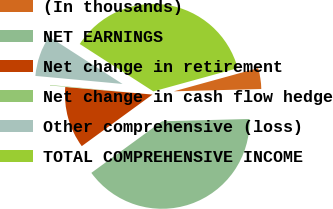<chart> <loc_0><loc_0><loc_500><loc_500><pie_chart><fcel>(In thousands)<fcel>NET EARNINGS<fcel>Net change in retirement<fcel>Net change in cash flow hedge<fcel>Other comprehensive (loss)<fcel>TOTAL COMPREHENSIVE INCOME<nl><fcel>3.86%<fcel>40.39%<fcel>11.41%<fcel>0.09%<fcel>7.64%<fcel>36.62%<nl></chart> 